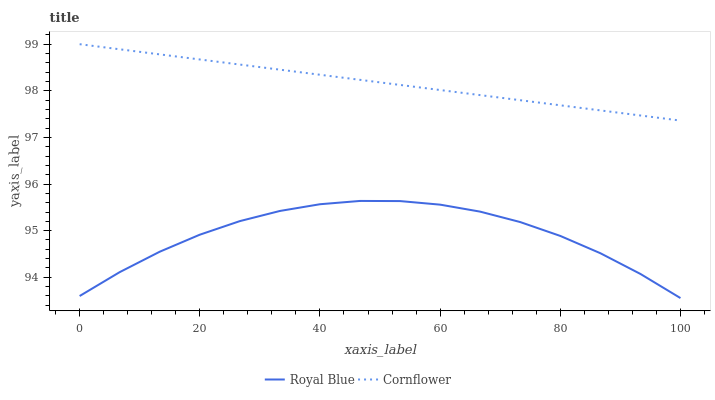Does Royal Blue have the minimum area under the curve?
Answer yes or no. Yes. Does Cornflower have the maximum area under the curve?
Answer yes or no. Yes. Does Cornflower have the minimum area under the curve?
Answer yes or no. No. Is Cornflower the smoothest?
Answer yes or no. Yes. Is Royal Blue the roughest?
Answer yes or no. Yes. Is Cornflower the roughest?
Answer yes or no. No. Does Royal Blue have the lowest value?
Answer yes or no. Yes. Does Cornflower have the lowest value?
Answer yes or no. No. Does Cornflower have the highest value?
Answer yes or no. Yes. Is Royal Blue less than Cornflower?
Answer yes or no. Yes. Is Cornflower greater than Royal Blue?
Answer yes or no. Yes. Does Royal Blue intersect Cornflower?
Answer yes or no. No. 